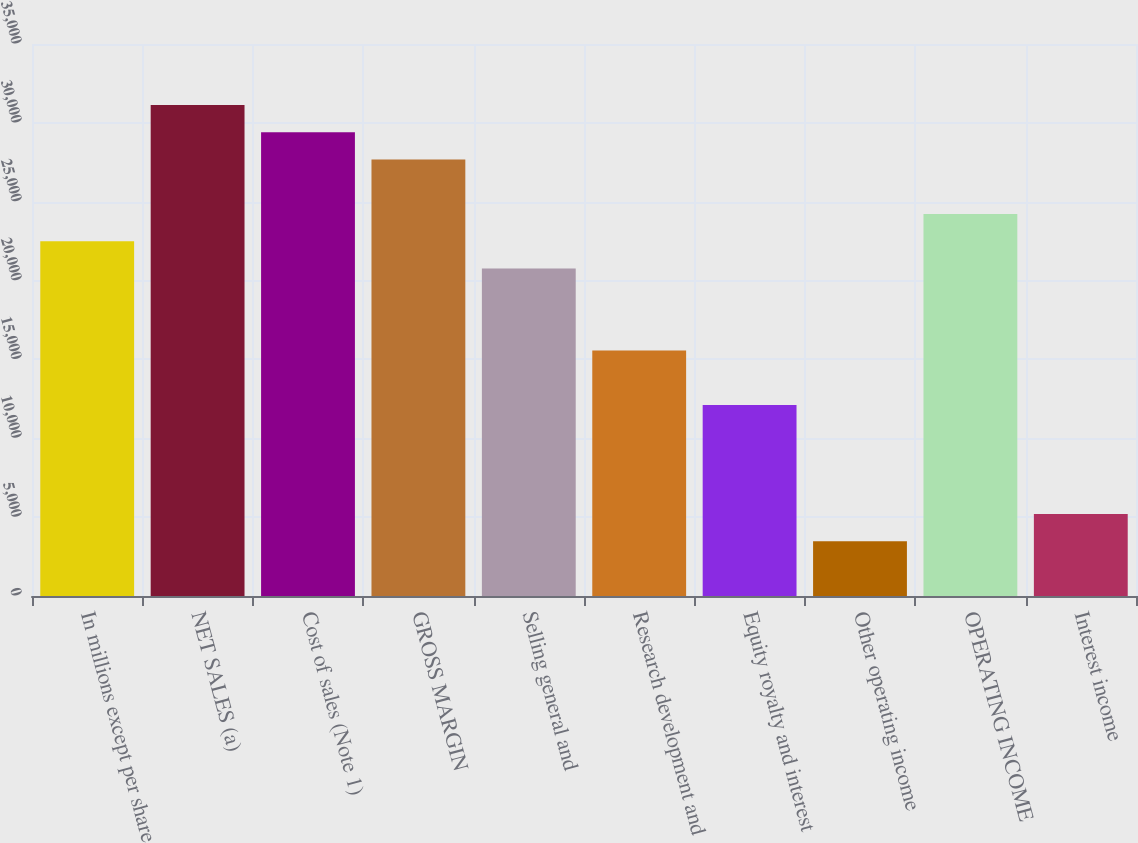Convert chart. <chart><loc_0><loc_0><loc_500><loc_500><bar_chart><fcel>In millions except per share<fcel>NET SALES (a)<fcel>Cost of sales (Note 1)<fcel>GROSS MARGIN<fcel>Selling general and<fcel>Research development and<fcel>Equity royalty and interest<fcel>Other operating income<fcel>OPERATING INCOME<fcel>Interest income<nl><fcel>22488.9<fcel>31135.5<fcel>29406.2<fcel>27676.9<fcel>20759.6<fcel>15571.7<fcel>12113.1<fcel>3466.53<fcel>24218.2<fcel>5195.84<nl></chart> 